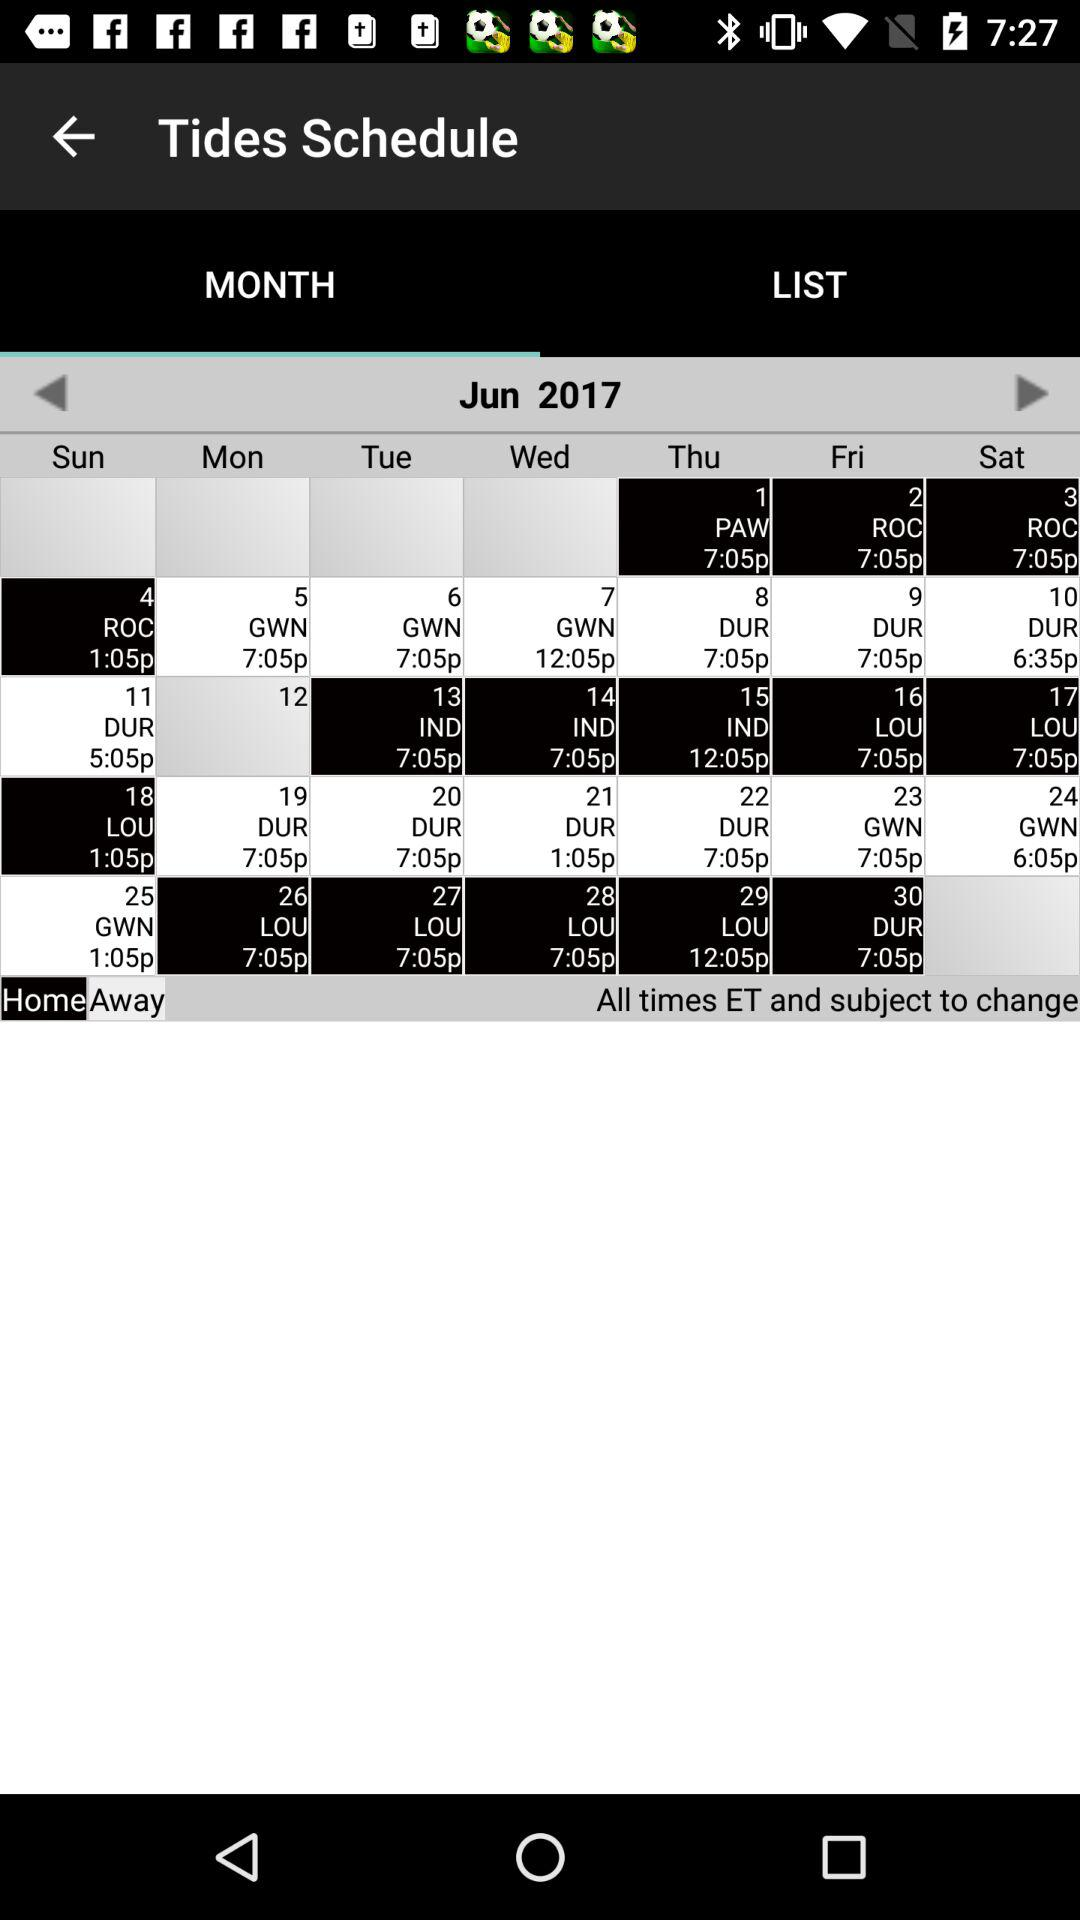Which day falls on June 21st, 2017? The day is Wednesday. 